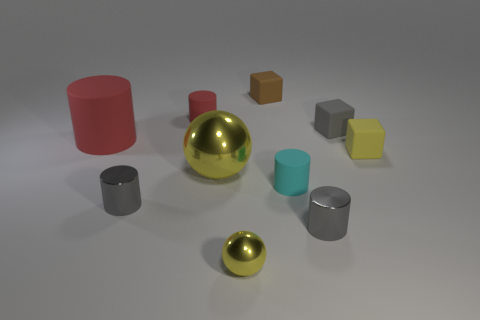Is the number of tiny metallic objects to the right of the tiny brown block the same as the number of tiny rubber cubes in front of the large yellow thing?
Your answer should be compact. No. What is the material of the large yellow thing that is the same shape as the small yellow metal thing?
Offer a terse response. Metal. What is the shape of the cyan matte object that is in front of the big thing that is behind the cube that is in front of the gray rubber thing?
Your answer should be compact. Cylinder. Are there more small cyan matte things behind the big cylinder than small yellow rubber objects?
Give a very brief answer. No. There is a tiny yellow thing that is to the right of the brown rubber block; does it have the same shape as the gray matte thing?
Your response must be concise. Yes. What material is the big thing in front of the big red matte thing?
Provide a succinct answer. Metal. What number of tiny brown objects have the same shape as the large metallic object?
Offer a terse response. 0. There is a gray cylinder left of the cyan rubber cylinder on the right side of the brown thing; what is its material?
Keep it short and to the point. Metal. There is a small object that is the same color as the large rubber cylinder; what is its shape?
Ensure brevity in your answer.  Cylinder. Are there any gray cylinders made of the same material as the big yellow sphere?
Your response must be concise. Yes. 